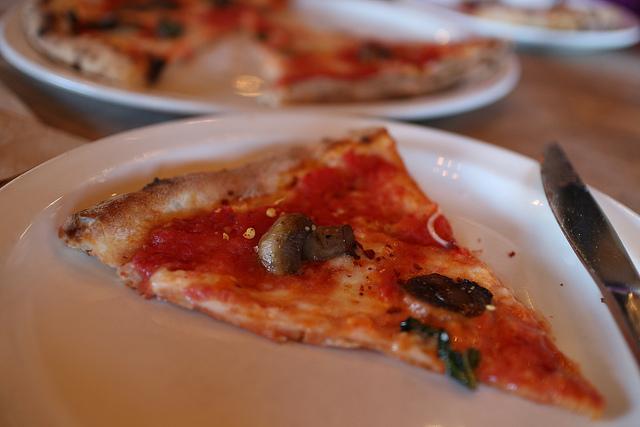Does this pizza look greasy?
Give a very brief answer. No. What shape is the pizza?
Keep it brief. Triangle. Is this good for someone with lactose intolerance?
Keep it brief. Yes. How many utensils do you see?
Quick response, please. 1. Is the pizza a deep dish or hand tossed?
Concise answer only. Hand tossed. How many plates are there?
Be succinct. 3. Do you need all these plates to serve one pizza?
Be succinct. Yes. Would this be served hot or cold?
Concise answer only. Hot. Where is mine at?
Keep it brief. Plate. 